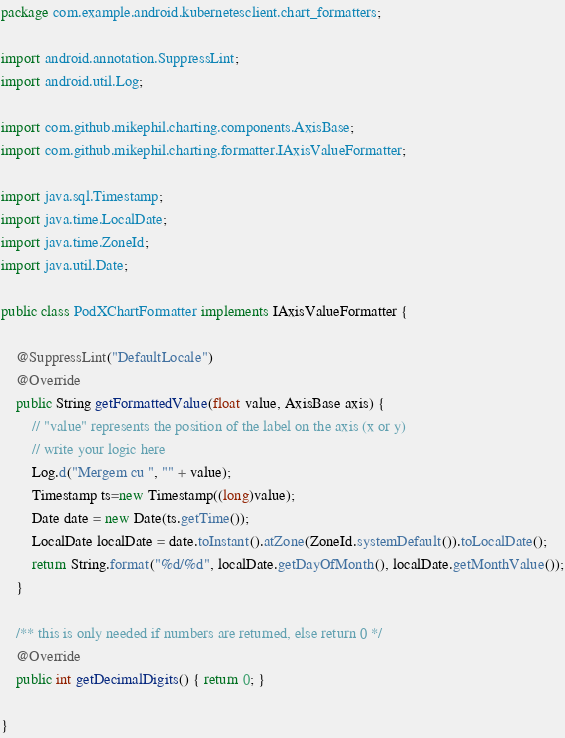<code> <loc_0><loc_0><loc_500><loc_500><_Java_>package com.example.android.kubernetesclient.chart_formatters;

import android.annotation.SuppressLint;
import android.util.Log;

import com.github.mikephil.charting.components.AxisBase;
import com.github.mikephil.charting.formatter.IAxisValueFormatter;

import java.sql.Timestamp;
import java.time.LocalDate;
import java.time.ZoneId;
import java.util.Date;

public class PodXChartFormatter implements IAxisValueFormatter {

    @SuppressLint("DefaultLocale")
    @Override
    public String getFormattedValue(float value, AxisBase axis) {
        // "value" represents the position of the label on the axis (x or y)
        // write your logic here
        Log.d("Mergem cu ", "" + value);
        Timestamp ts=new Timestamp((long)value);
        Date date = new Date(ts.getTime());
        LocalDate localDate = date.toInstant().atZone(ZoneId.systemDefault()).toLocalDate();
        return String.format("%d/%d", localDate.getDayOfMonth(), localDate.getMonthValue());
    }

    /** this is only needed if numbers are returned, else return 0 */
    @Override
    public int getDecimalDigits() { return 0; }

}
</code> 